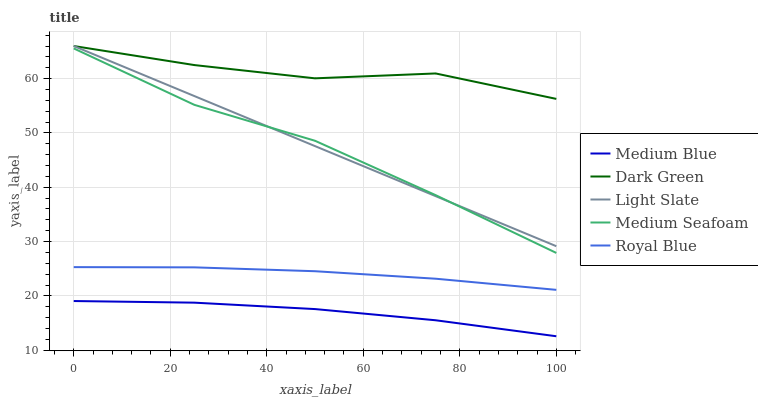Does Medium Blue have the minimum area under the curve?
Answer yes or no. Yes. Does Dark Green have the maximum area under the curve?
Answer yes or no. Yes. Does Royal Blue have the minimum area under the curve?
Answer yes or no. No. Does Royal Blue have the maximum area under the curve?
Answer yes or no. No. Is Light Slate the smoothest?
Answer yes or no. Yes. Is Dark Green the roughest?
Answer yes or no. Yes. Is Royal Blue the smoothest?
Answer yes or no. No. Is Royal Blue the roughest?
Answer yes or no. No. Does Medium Blue have the lowest value?
Answer yes or no. Yes. Does Royal Blue have the lowest value?
Answer yes or no. No. Does Dark Green have the highest value?
Answer yes or no. Yes. Does Royal Blue have the highest value?
Answer yes or no. No. Is Medium Blue less than Royal Blue?
Answer yes or no. Yes. Is Medium Seafoam greater than Medium Blue?
Answer yes or no. Yes. Does Dark Green intersect Light Slate?
Answer yes or no. Yes. Is Dark Green less than Light Slate?
Answer yes or no. No. Is Dark Green greater than Light Slate?
Answer yes or no. No. Does Medium Blue intersect Royal Blue?
Answer yes or no. No. 